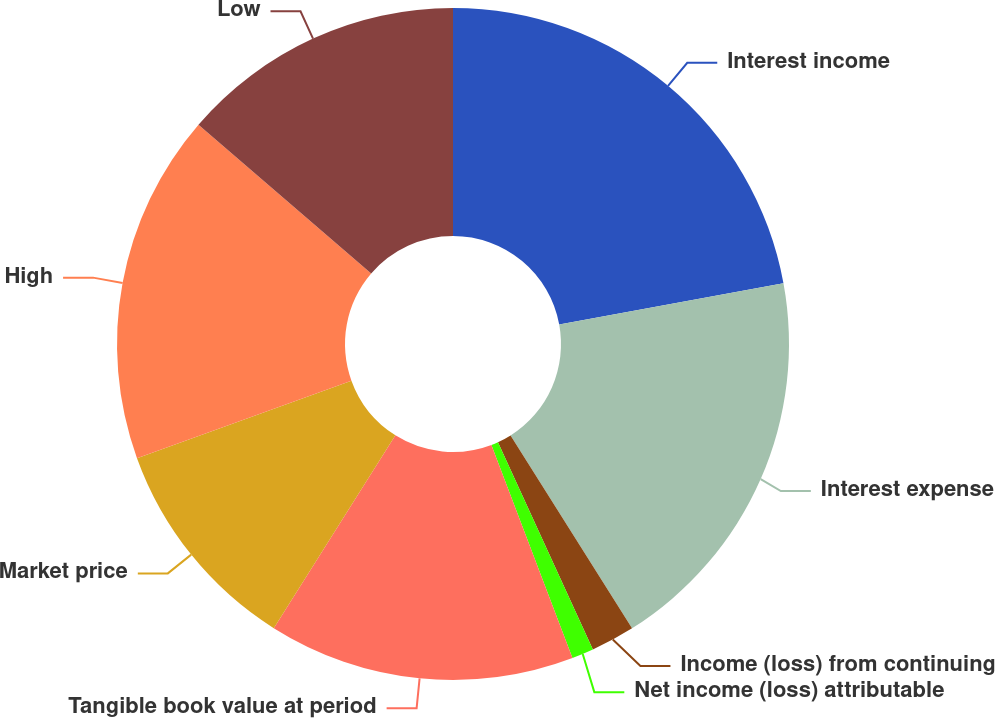<chart> <loc_0><loc_0><loc_500><loc_500><pie_chart><fcel>Interest income<fcel>Interest expense<fcel>Income (loss) from continuing<fcel>Net income (loss) attributable<fcel>Tangible book value at period<fcel>Market price<fcel>High<fcel>Low<nl><fcel>22.11%<fcel>18.95%<fcel>2.11%<fcel>1.05%<fcel>14.74%<fcel>10.53%<fcel>16.84%<fcel>13.68%<nl></chart> 